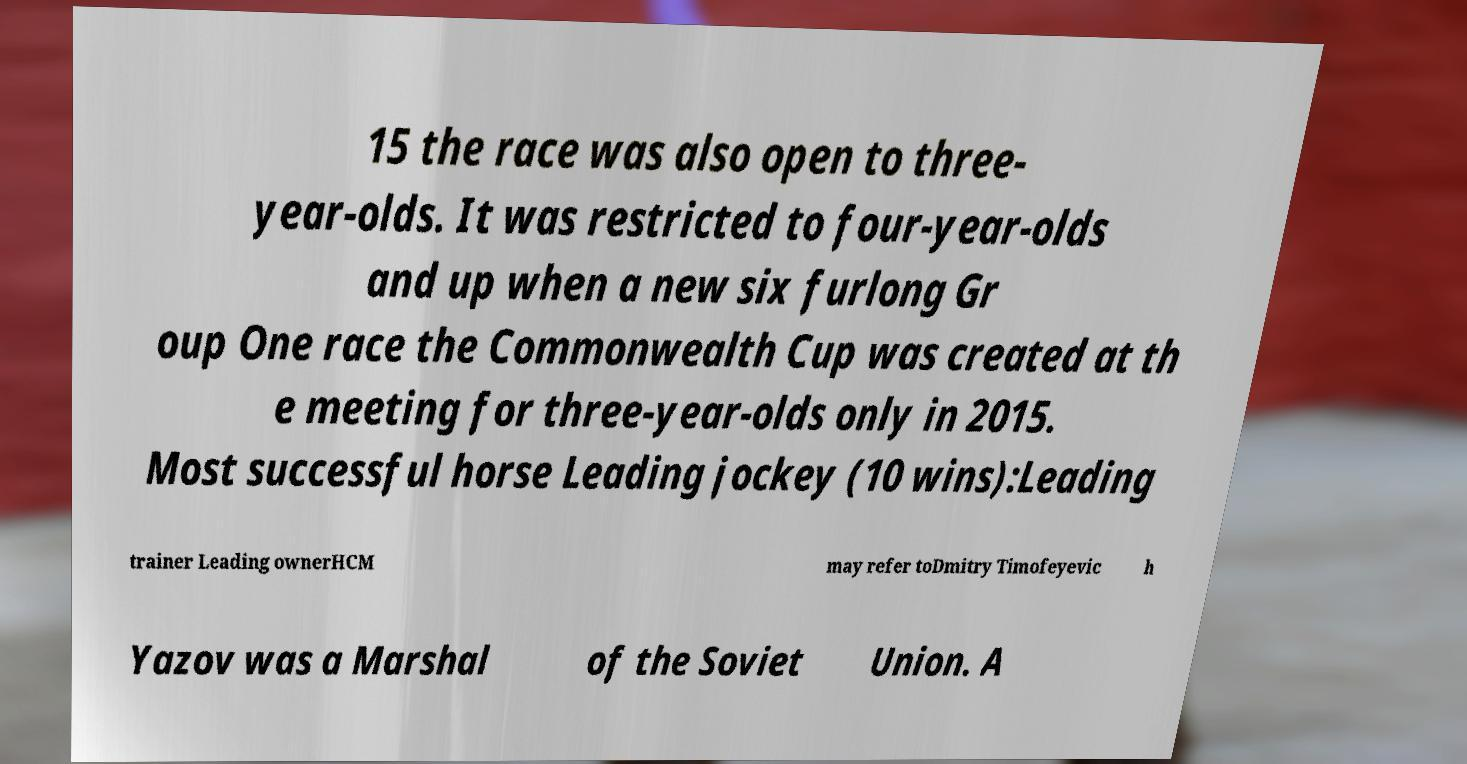For documentation purposes, I need the text within this image transcribed. Could you provide that? 15 the race was also open to three- year-olds. It was restricted to four-year-olds and up when a new six furlong Gr oup One race the Commonwealth Cup was created at th e meeting for three-year-olds only in 2015. Most successful horse Leading jockey (10 wins):Leading trainer Leading ownerHCM may refer toDmitry Timofeyevic h Yazov was a Marshal of the Soviet Union. A 